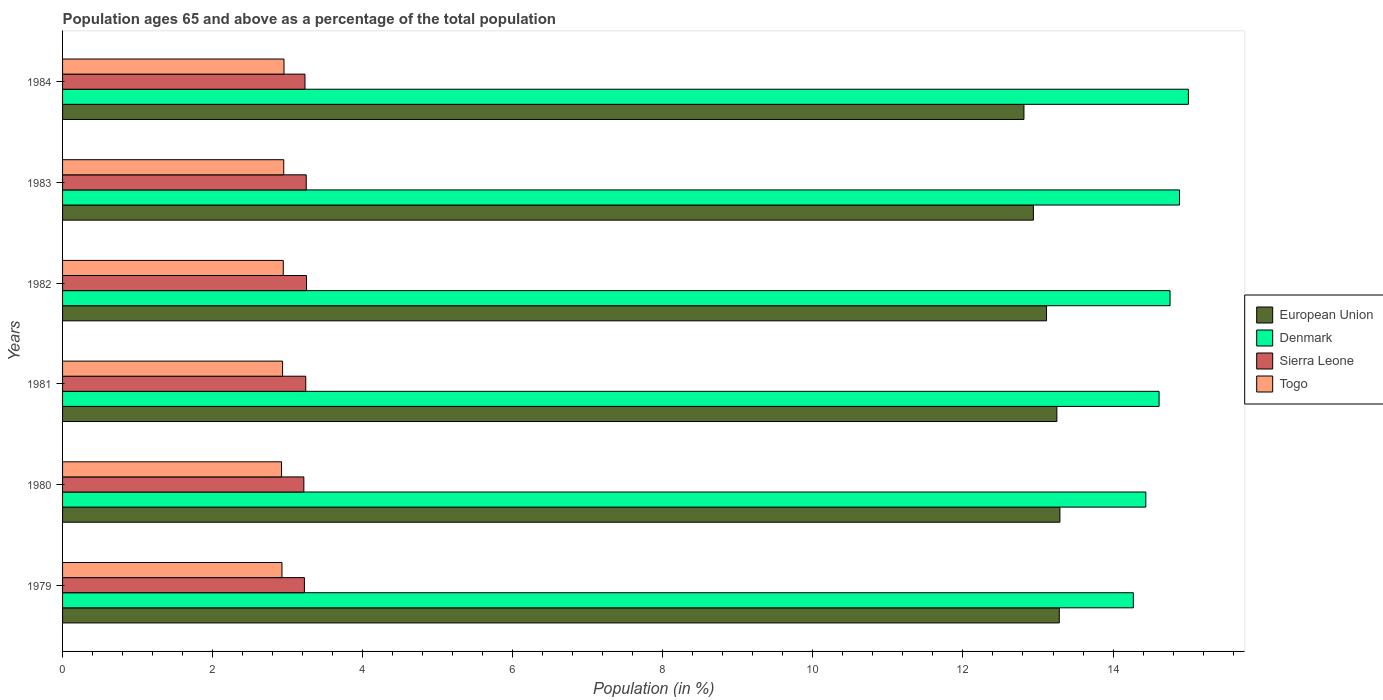Are the number of bars on each tick of the Y-axis equal?
Your answer should be compact. Yes. How many bars are there on the 3rd tick from the top?
Offer a terse response. 4. In how many cases, is the number of bars for a given year not equal to the number of legend labels?
Offer a very short reply. 0. What is the percentage of the population ages 65 and above in European Union in 1980?
Keep it short and to the point. 13.29. Across all years, what is the maximum percentage of the population ages 65 and above in European Union?
Give a very brief answer. 13.29. Across all years, what is the minimum percentage of the population ages 65 and above in Togo?
Keep it short and to the point. 2.92. In which year was the percentage of the population ages 65 and above in Sierra Leone maximum?
Offer a very short reply. 1982. In which year was the percentage of the population ages 65 and above in Denmark minimum?
Keep it short and to the point. 1979. What is the total percentage of the population ages 65 and above in Sierra Leone in the graph?
Make the answer very short. 19.41. What is the difference between the percentage of the population ages 65 and above in European Union in 1979 and that in 1983?
Keep it short and to the point. 0.35. What is the difference between the percentage of the population ages 65 and above in European Union in 1980 and the percentage of the population ages 65 and above in Sierra Leone in 1982?
Give a very brief answer. 10.04. What is the average percentage of the population ages 65 and above in Sierra Leone per year?
Give a very brief answer. 3.23. In the year 1980, what is the difference between the percentage of the population ages 65 and above in Denmark and percentage of the population ages 65 and above in Sierra Leone?
Your response must be concise. 11.22. In how many years, is the percentage of the population ages 65 and above in Sierra Leone greater than 3.6 ?
Make the answer very short. 0. What is the ratio of the percentage of the population ages 65 and above in Togo in 1980 to that in 1981?
Give a very brief answer. 1. Is the difference between the percentage of the population ages 65 and above in Denmark in 1982 and 1983 greater than the difference between the percentage of the population ages 65 and above in Sierra Leone in 1982 and 1983?
Your answer should be compact. No. What is the difference between the highest and the second highest percentage of the population ages 65 and above in European Union?
Provide a short and direct response. 0.01. What is the difference between the highest and the lowest percentage of the population ages 65 and above in Denmark?
Ensure brevity in your answer.  0.73. Is the sum of the percentage of the population ages 65 and above in Togo in 1982 and 1984 greater than the maximum percentage of the population ages 65 and above in Sierra Leone across all years?
Offer a terse response. Yes. Is it the case that in every year, the sum of the percentage of the population ages 65 and above in Togo and percentage of the population ages 65 and above in European Union is greater than the sum of percentage of the population ages 65 and above in Sierra Leone and percentage of the population ages 65 and above in Denmark?
Offer a very short reply. Yes. What does the 1st bar from the top in 1980 represents?
Offer a very short reply. Togo. What does the 3rd bar from the bottom in 1982 represents?
Your answer should be very brief. Sierra Leone. Is it the case that in every year, the sum of the percentage of the population ages 65 and above in European Union and percentage of the population ages 65 and above in Togo is greater than the percentage of the population ages 65 and above in Sierra Leone?
Provide a succinct answer. Yes. What is the difference between two consecutive major ticks on the X-axis?
Offer a very short reply. 2. Are the values on the major ticks of X-axis written in scientific E-notation?
Your answer should be very brief. No. Does the graph contain any zero values?
Offer a terse response. No. How many legend labels are there?
Ensure brevity in your answer.  4. How are the legend labels stacked?
Make the answer very short. Vertical. What is the title of the graph?
Provide a short and direct response. Population ages 65 and above as a percentage of the total population. Does "Uganda" appear as one of the legend labels in the graph?
Offer a terse response. No. What is the label or title of the X-axis?
Ensure brevity in your answer.  Population (in %). What is the Population (in %) in European Union in 1979?
Offer a terse response. 13.28. What is the Population (in %) in Denmark in 1979?
Give a very brief answer. 14.27. What is the Population (in %) in Sierra Leone in 1979?
Make the answer very short. 3.22. What is the Population (in %) of Togo in 1979?
Keep it short and to the point. 2.92. What is the Population (in %) in European Union in 1980?
Provide a succinct answer. 13.29. What is the Population (in %) in Denmark in 1980?
Your answer should be very brief. 14.44. What is the Population (in %) in Sierra Leone in 1980?
Provide a short and direct response. 3.22. What is the Population (in %) of Togo in 1980?
Offer a terse response. 2.92. What is the Population (in %) of European Union in 1981?
Give a very brief answer. 13.25. What is the Population (in %) of Denmark in 1981?
Keep it short and to the point. 14.61. What is the Population (in %) of Sierra Leone in 1981?
Offer a terse response. 3.24. What is the Population (in %) of Togo in 1981?
Offer a terse response. 2.93. What is the Population (in %) of European Union in 1982?
Keep it short and to the point. 13.11. What is the Population (in %) of Denmark in 1982?
Make the answer very short. 14.76. What is the Population (in %) in Sierra Leone in 1982?
Your response must be concise. 3.25. What is the Population (in %) of Togo in 1982?
Give a very brief answer. 2.94. What is the Population (in %) in European Union in 1983?
Your answer should be very brief. 12.94. What is the Population (in %) of Denmark in 1983?
Your answer should be compact. 14.89. What is the Population (in %) in Sierra Leone in 1983?
Your answer should be compact. 3.25. What is the Population (in %) of Togo in 1983?
Make the answer very short. 2.95. What is the Population (in %) in European Union in 1984?
Make the answer very short. 12.81. What is the Population (in %) of Denmark in 1984?
Offer a very short reply. 15. What is the Population (in %) in Sierra Leone in 1984?
Your answer should be very brief. 3.23. What is the Population (in %) of Togo in 1984?
Offer a very short reply. 2.95. Across all years, what is the maximum Population (in %) in European Union?
Provide a short and direct response. 13.29. Across all years, what is the maximum Population (in %) of Denmark?
Keep it short and to the point. 15. Across all years, what is the maximum Population (in %) of Sierra Leone?
Offer a terse response. 3.25. Across all years, what is the maximum Population (in %) of Togo?
Your answer should be very brief. 2.95. Across all years, what is the minimum Population (in %) in European Union?
Keep it short and to the point. 12.81. Across all years, what is the minimum Population (in %) of Denmark?
Offer a terse response. 14.27. Across all years, what is the minimum Population (in %) of Sierra Leone?
Give a very brief answer. 3.22. Across all years, what is the minimum Population (in %) of Togo?
Provide a succinct answer. 2.92. What is the total Population (in %) of European Union in the graph?
Offer a terse response. 78.69. What is the total Population (in %) in Denmark in the graph?
Provide a succinct answer. 87.97. What is the total Population (in %) in Sierra Leone in the graph?
Your answer should be very brief. 19.41. What is the total Population (in %) of Togo in the graph?
Provide a short and direct response. 17.62. What is the difference between the Population (in %) of European Union in 1979 and that in 1980?
Your answer should be compact. -0.01. What is the difference between the Population (in %) of Denmark in 1979 and that in 1980?
Ensure brevity in your answer.  -0.17. What is the difference between the Population (in %) in Sierra Leone in 1979 and that in 1980?
Offer a terse response. 0.01. What is the difference between the Population (in %) in Togo in 1979 and that in 1980?
Provide a succinct answer. 0.01. What is the difference between the Population (in %) in European Union in 1979 and that in 1981?
Your answer should be very brief. 0.03. What is the difference between the Population (in %) in Denmark in 1979 and that in 1981?
Provide a succinct answer. -0.34. What is the difference between the Population (in %) of Sierra Leone in 1979 and that in 1981?
Make the answer very short. -0.02. What is the difference between the Population (in %) in Togo in 1979 and that in 1981?
Provide a short and direct response. -0.01. What is the difference between the Population (in %) of European Union in 1979 and that in 1982?
Your answer should be compact. 0.17. What is the difference between the Population (in %) of Denmark in 1979 and that in 1982?
Your answer should be very brief. -0.49. What is the difference between the Population (in %) in Sierra Leone in 1979 and that in 1982?
Offer a terse response. -0.03. What is the difference between the Population (in %) in Togo in 1979 and that in 1982?
Make the answer very short. -0.02. What is the difference between the Population (in %) in European Union in 1979 and that in 1983?
Offer a terse response. 0.35. What is the difference between the Population (in %) in Denmark in 1979 and that in 1983?
Ensure brevity in your answer.  -0.62. What is the difference between the Population (in %) of Sierra Leone in 1979 and that in 1983?
Your response must be concise. -0.02. What is the difference between the Population (in %) in Togo in 1979 and that in 1983?
Your answer should be very brief. -0.02. What is the difference between the Population (in %) of European Union in 1979 and that in 1984?
Offer a very short reply. 0.47. What is the difference between the Population (in %) in Denmark in 1979 and that in 1984?
Your answer should be compact. -0.73. What is the difference between the Population (in %) in Sierra Leone in 1979 and that in 1984?
Provide a short and direct response. -0.01. What is the difference between the Population (in %) of Togo in 1979 and that in 1984?
Your answer should be very brief. -0.03. What is the difference between the Population (in %) in European Union in 1980 and that in 1981?
Make the answer very short. 0.04. What is the difference between the Population (in %) in Denmark in 1980 and that in 1981?
Your answer should be very brief. -0.18. What is the difference between the Population (in %) in Sierra Leone in 1980 and that in 1981?
Offer a very short reply. -0.03. What is the difference between the Population (in %) of Togo in 1980 and that in 1981?
Give a very brief answer. -0.01. What is the difference between the Population (in %) of European Union in 1980 and that in 1982?
Your response must be concise. 0.18. What is the difference between the Population (in %) in Denmark in 1980 and that in 1982?
Your answer should be very brief. -0.32. What is the difference between the Population (in %) of Sierra Leone in 1980 and that in 1982?
Your answer should be very brief. -0.04. What is the difference between the Population (in %) of Togo in 1980 and that in 1982?
Your answer should be very brief. -0.02. What is the difference between the Population (in %) of European Union in 1980 and that in 1983?
Offer a terse response. 0.35. What is the difference between the Population (in %) in Denmark in 1980 and that in 1983?
Make the answer very short. -0.45. What is the difference between the Population (in %) in Sierra Leone in 1980 and that in 1983?
Your response must be concise. -0.03. What is the difference between the Population (in %) of Togo in 1980 and that in 1983?
Offer a very short reply. -0.03. What is the difference between the Population (in %) in European Union in 1980 and that in 1984?
Your answer should be very brief. 0.48. What is the difference between the Population (in %) in Denmark in 1980 and that in 1984?
Provide a short and direct response. -0.57. What is the difference between the Population (in %) in Sierra Leone in 1980 and that in 1984?
Keep it short and to the point. -0.01. What is the difference between the Population (in %) of Togo in 1980 and that in 1984?
Offer a terse response. -0.03. What is the difference between the Population (in %) of European Union in 1981 and that in 1982?
Your answer should be compact. 0.14. What is the difference between the Population (in %) of Denmark in 1981 and that in 1982?
Offer a very short reply. -0.15. What is the difference between the Population (in %) of Sierra Leone in 1981 and that in 1982?
Your answer should be very brief. -0.01. What is the difference between the Population (in %) of Togo in 1981 and that in 1982?
Offer a terse response. -0.01. What is the difference between the Population (in %) in European Union in 1981 and that in 1983?
Your answer should be very brief. 0.31. What is the difference between the Population (in %) in Denmark in 1981 and that in 1983?
Your answer should be very brief. -0.27. What is the difference between the Population (in %) of Sierra Leone in 1981 and that in 1983?
Give a very brief answer. -0.01. What is the difference between the Population (in %) in Togo in 1981 and that in 1983?
Ensure brevity in your answer.  -0.02. What is the difference between the Population (in %) of European Union in 1981 and that in 1984?
Your answer should be compact. 0.44. What is the difference between the Population (in %) in Denmark in 1981 and that in 1984?
Give a very brief answer. -0.39. What is the difference between the Population (in %) of Sierra Leone in 1981 and that in 1984?
Provide a short and direct response. 0.01. What is the difference between the Population (in %) in Togo in 1981 and that in 1984?
Keep it short and to the point. -0.02. What is the difference between the Population (in %) of European Union in 1982 and that in 1983?
Offer a very short reply. 0.17. What is the difference between the Population (in %) in Denmark in 1982 and that in 1983?
Offer a terse response. -0.13. What is the difference between the Population (in %) of Sierra Leone in 1982 and that in 1983?
Your answer should be compact. 0. What is the difference between the Population (in %) of Togo in 1982 and that in 1983?
Give a very brief answer. -0.01. What is the difference between the Population (in %) in European Union in 1982 and that in 1984?
Make the answer very short. 0.3. What is the difference between the Population (in %) in Denmark in 1982 and that in 1984?
Your response must be concise. -0.24. What is the difference between the Population (in %) in Sierra Leone in 1982 and that in 1984?
Keep it short and to the point. 0.02. What is the difference between the Population (in %) of Togo in 1982 and that in 1984?
Ensure brevity in your answer.  -0.01. What is the difference between the Population (in %) of European Union in 1983 and that in 1984?
Ensure brevity in your answer.  0.13. What is the difference between the Population (in %) in Denmark in 1983 and that in 1984?
Provide a succinct answer. -0.12. What is the difference between the Population (in %) of Sierra Leone in 1983 and that in 1984?
Make the answer very short. 0.02. What is the difference between the Population (in %) of Togo in 1983 and that in 1984?
Provide a short and direct response. -0. What is the difference between the Population (in %) in European Union in 1979 and the Population (in %) in Denmark in 1980?
Your response must be concise. -1.15. What is the difference between the Population (in %) in European Union in 1979 and the Population (in %) in Sierra Leone in 1980?
Provide a short and direct response. 10.07. What is the difference between the Population (in %) in European Union in 1979 and the Population (in %) in Togo in 1980?
Ensure brevity in your answer.  10.37. What is the difference between the Population (in %) in Denmark in 1979 and the Population (in %) in Sierra Leone in 1980?
Your answer should be very brief. 11.05. What is the difference between the Population (in %) of Denmark in 1979 and the Population (in %) of Togo in 1980?
Your answer should be compact. 11.35. What is the difference between the Population (in %) in Sierra Leone in 1979 and the Population (in %) in Togo in 1980?
Offer a very short reply. 0.3. What is the difference between the Population (in %) of European Union in 1979 and the Population (in %) of Denmark in 1981?
Keep it short and to the point. -1.33. What is the difference between the Population (in %) in European Union in 1979 and the Population (in %) in Sierra Leone in 1981?
Ensure brevity in your answer.  10.04. What is the difference between the Population (in %) of European Union in 1979 and the Population (in %) of Togo in 1981?
Offer a very short reply. 10.35. What is the difference between the Population (in %) in Denmark in 1979 and the Population (in %) in Sierra Leone in 1981?
Keep it short and to the point. 11.03. What is the difference between the Population (in %) in Denmark in 1979 and the Population (in %) in Togo in 1981?
Offer a terse response. 11.34. What is the difference between the Population (in %) of Sierra Leone in 1979 and the Population (in %) of Togo in 1981?
Keep it short and to the point. 0.29. What is the difference between the Population (in %) of European Union in 1979 and the Population (in %) of Denmark in 1982?
Make the answer very short. -1.48. What is the difference between the Population (in %) in European Union in 1979 and the Population (in %) in Sierra Leone in 1982?
Keep it short and to the point. 10.03. What is the difference between the Population (in %) of European Union in 1979 and the Population (in %) of Togo in 1982?
Your response must be concise. 10.34. What is the difference between the Population (in %) of Denmark in 1979 and the Population (in %) of Sierra Leone in 1982?
Your answer should be very brief. 11.02. What is the difference between the Population (in %) of Denmark in 1979 and the Population (in %) of Togo in 1982?
Your answer should be very brief. 11.33. What is the difference between the Population (in %) in Sierra Leone in 1979 and the Population (in %) in Togo in 1982?
Give a very brief answer. 0.28. What is the difference between the Population (in %) in European Union in 1979 and the Population (in %) in Denmark in 1983?
Offer a terse response. -1.6. What is the difference between the Population (in %) in European Union in 1979 and the Population (in %) in Sierra Leone in 1983?
Give a very brief answer. 10.04. What is the difference between the Population (in %) in European Union in 1979 and the Population (in %) in Togo in 1983?
Keep it short and to the point. 10.34. What is the difference between the Population (in %) of Denmark in 1979 and the Population (in %) of Sierra Leone in 1983?
Give a very brief answer. 11.02. What is the difference between the Population (in %) of Denmark in 1979 and the Population (in %) of Togo in 1983?
Make the answer very short. 11.32. What is the difference between the Population (in %) in Sierra Leone in 1979 and the Population (in %) in Togo in 1983?
Make the answer very short. 0.28. What is the difference between the Population (in %) of European Union in 1979 and the Population (in %) of Denmark in 1984?
Offer a very short reply. -1.72. What is the difference between the Population (in %) of European Union in 1979 and the Population (in %) of Sierra Leone in 1984?
Make the answer very short. 10.05. What is the difference between the Population (in %) in European Union in 1979 and the Population (in %) in Togo in 1984?
Your answer should be compact. 10.33. What is the difference between the Population (in %) of Denmark in 1979 and the Population (in %) of Sierra Leone in 1984?
Your answer should be very brief. 11.04. What is the difference between the Population (in %) in Denmark in 1979 and the Population (in %) in Togo in 1984?
Provide a succinct answer. 11.32. What is the difference between the Population (in %) in Sierra Leone in 1979 and the Population (in %) in Togo in 1984?
Ensure brevity in your answer.  0.27. What is the difference between the Population (in %) of European Union in 1980 and the Population (in %) of Denmark in 1981?
Offer a very short reply. -1.32. What is the difference between the Population (in %) of European Union in 1980 and the Population (in %) of Sierra Leone in 1981?
Give a very brief answer. 10.05. What is the difference between the Population (in %) in European Union in 1980 and the Population (in %) in Togo in 1981?
Offer a terse response. 10.36. What is the difference between the Population (in %) of Denmark in 1980 and the Population (in %) of Sierra Leone in 1981?
Your answer should be compact. 11.2. What is the difference between the Population (in %) of Denmark in 1980 and the Population (in %) of Togo in 1981?
Provide a succinct answer. 11.5. What is the difference between the Population (in %) of Sierra Leone in 1980 and the Population (in %) of Togo in 1981?
Offer a very short reply. 0.28. What is the difference between the Population (in %) of European Union in 1980 and the Population (in %) of Denmark in 1982?
Ensure brevity in your answer.  -1.47. What is the difference between the Population (in %) in European Union in 1980 and the Population (in %) in Sierra Leone in 1982?
Provide a short and direct response. 10.04. What is the difference between the Population (in %) in European Union in 1980 and the Population (in %) in Togo in 1982?
Give a very brief answer. 10.35. What is the difference between the Population (in %) of Denmark in 1980 and the Population (in %) of Sierra Leone in 1982?
Offer a terse response. 11.19. What is the difference between the Population (in %) of Denmark in 1980 and the Population (in %) of Togo in 1982?
Your answer should be very brief. 11.5. What is the difference between the Population (in %) of Sierra Leone in 1980 and the Population (in %) of Togo in 1982?
Ensure brevity in your answer.  0.27. What is the difference between the Population (in %) in European Union in 1980 and the Population (in %) in Denmark in 1983?
Offer a terse response. -1.59. What is the difference between the Population (in %) of European Union in 1980 and the Population (in %) of Sierra Leone in 1983?
Provide a short and direct response. 10.04. What is the difference between the Population (in %) in European Union in 1980 and the Population (in %) in Togo in 1983?
Offer a terse response. 10.34. What is the difference between the Population (in %) in Denmark in 1980 and the Population (in %) in Sierra Leone in 1983?
Offer a very short reply. 11.19. What is the difference between the Population (in %) of Denmark in 1980 and the Population (in %) of Togo in 1983?
Offer a very short reply. 11.49. What is the difference between the Population (in %) in Sierra Leone in 1980 and the Population (in %) in Togo in 1983?
Your response must be concise. 0.27. What is the difference between the Population (in %) in European Union in 1980 and the Population (in %) in Denmark in 1984?
Make the answer very short. -1.71. What is the difference between the Population (in %) of European Union in 1980 and the Population (in %) of Sierra Leone in 1984?
Offer a very short reply. 10.06. What is the difference between the Population (in %) of European Union in 1980 and the Population (in %) of Togo in 1984?
Give a very brief answer. 10.34. What is the difference between the Population (in %) of Denmark in 1980 and the Population (in %) of Sierra Leone in 1984?
Give a very brief answer. 11.21. What is the difference between the Population (in %) of Denmark in 1980 and the Population (in %) of Togo in 1984?
Offer a very short reply. 11.49. What is the difference between the Population (in %) in Sierra Leone in 1980 and the Population (in %) in Togo in 1984?
Your response must be concise. 0.26. What is the difference between the Population (in %) in European Union in 1981 and the Population (in %) in Denmark in 1982?
Give a very brief answer. -1.51. What is the difference between the Population (in %) of European Union in 1981 and the Population (in %) of Sierra Leone in 1982?
Offer a very short reply. 10. What is the difference between the Population (in %) of European Union in 1981 and the Population (in %) of Togo in 1982?
Your answer should be very brief. 10.31. What is the difference between the Population (in %) in Denmark in 1981 and the Population (in %) in Sierra Leone in 1982?
Your response must be concise. 11.36. What is the difference between the Population (in %) of Denmark in 1981 and the Population (in %) of Togo in 1982?
Offer a very short reply. 11.67. What is the difference between the Population (in %) in Sierra Leone in 1981 and the Population (in %) in Togo in 1982?
Offer a very short reply. 0.3. What is the difference between the Population (in %) of European Union in 1981 and the Population (in %) of Denmark in 1983?
Provide a short and direct response. -1.63. What is the difference between the Population (in %) in European Union in 1981 and the Population (in %) in Sierra Leone in 1983?
Give a very brief answer. 10. What is the difference between the Population (in %) in European Union in 1981 and the Population (in %) in Togo in 1983?
Provide a short and direct response. 10.3. What is the difference between the Population (in %) of Denmark in 1981 and the Population (in %) of Sierra Leone in 1983?
Give a very brief answer. 11.37. What is the difference between the Population (in %) in Denmark in 1981 and the Population (in %) in Togo in 1983?
Your answer should be very brief. 11.67. What is the difference between the Population (in %) of Sierra Leone in 1981 and the Population (in %) of Togo in 1983?
Your answer should be very brief. 0.29. What is the difference between the Population (in %) of European Union in 1981 and the Population (in %) of Denmark in 1984?
Your answer should be very brief. -1.75. What is the difference between the Population (in %) in European Union in 1981 and the Population (in %) in Sierra Leone in 1984?
Your answer should be very brief. 10.02. What is the difference between the Population (in %) in European Union in 1981 and the Population (in %) in Togo in 1984?
Provide a short and direct response. 10.3. What is the difference between the Population (in %) of Denmark in 1981 and the Population (in %) of Sierra Leone in 1984?
Your answer should be compact. 11.38. What is the difference between the Population (in %) in Denmark in 1981 and the Population (in %) in Togo in 1984?
Provide a succinct answer. 11.66. What is the difference between the Population (in %) in Sierra Leone in 1981 and the Population (in %) in Togo in 1984?
Your answer should be compact. 0.29. What is the difference between the Population (in %) of European Union in 1982 and the Population (in %) of Denmark in 1983?
Provide a succinct answer. -1.77. What is the difference between the Population (in %) of European Union in 1982 and the Population (in %) of Sierra Leone in 1983?
Your answer should be very brief. 9.87. What is the difference between the Population (in %) in European Union in 1982 and the Population (in %) in Togo in 1983?
Your response must be concise. 10.17. What is the difference between the Population (in %) in Denmark in 1982 and the Population (in %) in Sierra Leone in 1983?
Make the answer very short. 11.51. What is the difference between the Population (in %) of Denmark in 1982 and the Population (in %) of Togo in 1983?
Provide a succinct answer. 11.81. What is the difference between the Population (in %) of Sierra Leone in 1982 and the Population (in %) of Togo in 1983?
Keep it short and to the point. 0.3. What is the difference between the Population (in %) of European Union in 1982 and the Population (in %) of Denmark in 1984?
Keep it short and to the point. -1.89. What is the difference between the Population (in %) of European Union in 1982 and the Population (in %) of Sierra Leone in 1984?
Give a very brief answer. 9.88. What is the difference between the Population (in %) of European Union in 1982 and the Population (in %) of Togo in 1984?
Ensure brevity in your answer.  10.16. What is the difference between the Population (in %) of Denmark in 1982 and the Population (in %) of Sierra Leone in 1984?
Offer a very short reply. 11.53. What is the difference between the Population (in %) in Denmark in 1982 and the Population (in %) in Togo in 1984?
Your answer should be compact. 11.81. What is the difference between the Population (in %) in Sierra Leone in 1982 and the Population (in %) in Togo in 1984?
Your answer should be very brief. 0.3. What is the difference between the Population (in %) in European Union in 1983 and the Population (in %) in Denmark in 1984?
Keep it short and to the point. -2.07. What is the difference between the Population (in %) of European Union in 1983 and the Population (in %) of Sierra Leone in 1984?
Your answer should be compact. 9.71. What is the difference between the Population (in %) of European Union in 1983 and the Population (in %) of Togo in 1984?
Your response must be concise. 9.99. What is the difference between the Population (in %) in Denmark in 1983 and the Population (in %) in Sierra Leone in 1984?
Make the answer very short. 11.66. What is the difference between the Population (in %) of Denmark in 1983 and the Population (in %) of Togo in 1984?
Offer a very short reply. 11.94. What is the difference between the Population (in %) of Sierra Leone in 1983 and the Population (in %) of Togo in 1984?
Make the answer very short. 0.3. What is the average Population (in %) in European Union per year?
Give a very brief answer. 13.12. What is the average Population (in %) in Denmark per year?
Keep it short and to the point. 14.66. What is the average Population (in %) of Sierra Leone per year?
Keep it short and to the point. 3.23. What is the average Population (in %) in Togo per year?
Ensure brevity in your answer.  2.94. In the year 1979, what is the difference between the Population (in %) of European Union and Population (in %) of Denmark?
Your answer should be compact. -0.99. In the year 1979, what is the difference between the Population (in %) in European Union and Population (in %) in Sierra Leone?
Your answer should be very brief. 10.06. In the year 1979, what is the difference between the Population (in %) of European Union and Population (in %) of Togo?
Offer a very short reply. 10.36. In the year 1979, what is the difference between the Population (in %) of Denmark and Population (in %) of Sierra Leone?
Give a very brief answer. 11.05. In the year 1979, what is the difference between the Population (in %) in Denmark and Population (in %) in Togo?
Your answer should be very brief. 11.35. In the year 1979, what is the difference between the Population (in %) in Sierra Leone and Population (in %) in Togo?
Keep it short and to the point. 0.3. In the year 1980, what is the difference between the Population (in %) of European Union and Population (in %) of Denmark?
Offer a terse response. -1.15. In the year 1980, what is the difference between the Population (in %) in European Union and Population (in %) in Sierra Leone?
Provide a short and direct response. 10.08. In the year 1980, what is the difference between the Population (in %) in European Union and Population (in %) in Togo?
Your response must be concise. 10.37. In the year 1980, what is the difference between the Population (in %) of Denmark and Population (in %) of Sierra Leone?
Ensure brevity in your answer.  11.22. In the year 1980, what is the difference between the Population (in %) of Denmark and Population (in %) of Togo?
Your answer should be very brief. 11.52. In the year 1980, what is the difference between the Population (in %) of Sierra Leone and Population (in %) of Togo?
Ensure brevity in your answer.  0.3. In the year 1981, what is the difference between the Population (in %) in European Union and Population (in %) in Denmark?
Ensure brevity in your answer.  -1.36. In the year 1981, what is the difference between the Population (in %) in European Union and Population (in %) in Sierra Leone?
Your answer should be compact. 10.01. In the year 1981, what is the difference between the Population (in %) of European Union and Population (in %) of Togo?
Offer a very short reply. 10.32. In the year 1981, what is the difference between the Population (in %) of Denmark and Population (in %) of Sierra Leone?
Give a very brief answer. 11.37. In the year 1981, what is the difference between the Population (in %) in Denmark and Population (in %) in Togo?
Make the answer very short. 11.68. In the year 1981, what is the difference between the Population (in %) in Sierra Leone and Population (in %) in Togo?
Make the answer very short. 0.31. In the year 1982, what is the difference between the Population (in %) in European Union and Population (in %) in Denmark?
Provide a short and direct response. -1.65. In the year 1982, what is the difference between the Population (in %) of European Union and Population (in %) of Sierra Leone?
Offer a terse response. 9.86. In the year 1982, what is the difference between the Population (in %) of European Union and Population (in %) of Togo?
Provide a short and direct response. 10.17. In the year 1982, what is the difference between the Population (in %) of Denmark and Population (in %) of Sierra Leone?
Your answer should be very brief. 11.51. In the year 1982, what is the difference between the Population (in %) of Denmark and Population (in %) of Togo?
Offer a terse response. 11.82. In the year 1982, what is the difference between the Population (in %) in Sierra Leone and Population (in %) in Togo?
Your answer should be compact. 0.31. In the year 1983, what is the difference between the Population (in %) in European Union and Population (in %) in Denmark?
Give a very brief answer. -1.95. In the year 1983, what is the difference between the Population (in %) in European Union and Population (in %) in Sierra Leone?
Make the answer very short. 9.69. In the year 1983, what is the difference between the Population (in %) in European Union and Population (in %) in Togo?
Offer a very short reply. 9.99. In the year 1983, what is the difference between the Population (in %) of Denmark and Population (in %) of Sierra Leone?
Provide a succinct answer. 11.64. In the year 1983, what is the difference between the Population (in %) in Denmark and Population (in %) in Togo?
Offer a terse response. 11.94. In the year 1983, what is the difference between the Population (in %) of Sierra Leone and Population (in %) of Togo?
Your answer should be very brief. 0.3. In the year 1984, what is the difference between the Population (in %) in European Union and Population (in %) in Denmark?
Keep it short and to the point. -2.19. In the year 1984, what is the difference between the Population (in %) of European Union and Population (in %) of Sierra Leone?
Provide a short and direct response. 9.58. In the year 1984, what is the difference between the Population (in %) in European Union and Population (in %) in Togo?
Offer a very short reply. 9.86. In the year 1984, what is the difference between the Population (in %) of Denmark and Population (in %) of Sierra Leone?
Make the answer very short. 11.77. In the year 1984, what is the difference between the Population (in %) of Denmark and Population (in %) of Togo?
Keep it short and to the point. 12.05. In the year 1984, what is the difference between the Population (in %) of Sierra Leone and Population (in %) of Togo?
Give a very brief answer. 0.28. What is the ratio of the Population (in %) of European Union in 1979 to that in 1980?
Your answer should be compact. 1. What is the ratio of the Population (in %) of Denmark in 1979 to that in 1980?
Your answer should be very brief. 0.99. What is the ratio of the Population (in %) in Togo in 1979 to that in 1980?
Offer a very short reply. 1. What is the ratio of the Population (in %) of European Union in 1979 to that in 1981?
Give a very brief answer. 1. What is the ratio of the Population (in %) in Denmark in 1979 to that in 1981?
Provide a succinct answer. 0.98. What is the ratio of the Population (in %) in European Union in 1979 to that in 1982?
Your answer should be very brief. 1.01. What is the ratio of the Population (in %) of Denmark in 1979 to that in 1982?
Provide a succinct answer. 0.97. What is the ratio of the Population (in %) in Sierra Leone in 1979 to that in 1982?
Keep it short and to the point. 0.99. What is the ratio of the Population (in %) in European Union in 1979 to that in 1983?
Your answer should be very brief. 1.03. What is the ratio of the Population (in %) of Denmark in 1979 to that in 1983?
Give a very brief answer. 0.96. What is the ratio of the Population (in %) in European Union in 1979 to that in 1984?
Your answer should be compact. 1.04. What is the ratio of the Population (in %) in Denmark in 1979 to that in 1984?
Make the answer very short. 0.95. What is the ratio of the Population (in %) of Sierra Leone in 1979 to that in 1984?
Provide a short and direct response. 1. What is the ratio of the Population (in %) in Togo in 1979 to that in 1984?
Your answer should be very brief. 0.99. What is the ratio of the Population (in %) of Denmark in 1980 to that in 1981?
Give a very brief answer. 0.99. What is the ratio of the Population (in %) in Togo in 1980 to that in 1981?
Offer a very short reply. 1. What is the ratio of the Population (in %) of European Union in 1980 to that in 1982?
Your answer should be very brief. 1.01. What is the ratio of the Population (in %) in Denmark in 1980 to that in 1982?
Your response must be concise. 0.98. What is the ratio of the Population (in %) in European Union in 1980 to that in 1983?
Your answer should be compact. 1.03. What is the ratio of the Population (in %) in Denmark in 1980 to that in 1983?
Give a very brief answer. 0.97. What is the ratio of the Population (in %) of Sierra Leone in 1980 to that in 1983?
Ensure brevity in your answer.  0.99. What is the ratio of the Population (in %) in Togo in 1980 to that in 1983?
Offer a terse response. 0.99. What is the ratio of the Population (in %) in European Union in 1980 to that in 1984?
Keep it short and to the point. 1.04. What is the ratio of the Population (in %) in Denmark in 1980 to that in 1984?
Provide a short and direct response. 0.96. What is the ratio of the Population (in %) in Togo in 1980 to that in 1984?
Your response must be concise. 0.99. What is the ratio of the Population (in %) of European Union in 1981 to that in 1982?
Ensure brevity in your answer.  1.01. What is the ratio of the Population (in %) in Denmark in 1981 to that in 1982?
Your answer should be compact. 0.99. What is the ratio of the Population (in %) in Sierra Leone in 1981 to that in 1982?
Ensure brevity in your answer.  1. What is the ratio of the Population (in %) in Togo in 1981 to that in 1982?
Provide a succinct answer. 1. What is the ratio of the Population (in %) of European Union in 1981 to that in 1983?
Your response must be concise. 1.02. What is the ratio of the Population (in %) of Denmark in 1981 to that in 1983?
Provide a succinct answer. 0.98. What is the ratio of the Population (in %) of Sierra Leone in 1981 to that in 1983?
Your response must be concise. 1. What is the ratio of the Population (in %) in Togo in 1981 to that in 1983?
Keep it short and to the point. 0.99. What is the ratio of the Population (in %) of European Union in 1981 to that in 1984?
Provide a short and direct response. 1.03. What is the ratio of the Population (in %) of Sierra Leone in 1981 to that in 1984?
Offer a very short reply. 1. What is the ratio of the Population (in %) of Togo in 1981 to that in 1984?
Your answer should be very brief. 0.99. What is the ratio of the Population (in %) of European Union in 1982 to that in 1983?
Offer a terse response. 1.01. What is the ratio of the Population (in %) of Denmark in 1982 to that in 1983?
Your answer should be compact. 0.99. What is the ratio of the Population (in %) in European Union in 1982 to that in 1984?
Keep it short and to the point. 1.02. What is the ratio of the Population (in %) in Denmark in 1982 to that in 1984?
Your answer should be very brief. 0.98. What is the ratio of the Population (in %) in Sierra Leone in 1982 to that in 1984?
Offer a terse response. 1.01. What is the ratio of the Population (in %) in European Union in 1983 to that in 1984?
Provide a succinct answer. 1.01. What is the ratio of the Population (in %) in Denmark in 1983 to that in 1984?
Provide a succinct answer. 0.99. What is the ratio of the Population (in %) of Sierra Leone in 1983 to that in 1984?
Ensure brevity in your answer.  1.01. What is the difference between the highest and the second highest Population (in %) in European Union?
Offer a terse response. 0.01. What is the difference between the highest and the second highest Population (in %) in Denmark?
Your answer should be compact. 0.12. What is the difference between the highest and the second highest Population (in %) of Sierra Leone?
Offer a very short reply. 0. What is the difference between the highest and the second highest Population (in %) in Togo?
Provide a succinct answer. 0. What is the difference between the highest and the lowest Population (in %) in European Union?
Make the answer very short. 0.48. What is the difference between the highest and the lowest Population (in %) of Denmark?
Make the answer very short. 0.73. What is the difference between the highest and the lowest Population (in %) of Sierra Leone?
Provide a short and direct response. 0.04. What is the difference between the highest and the lowest Population (in %) of Togo?
Give a very brief answer. 0.03. 